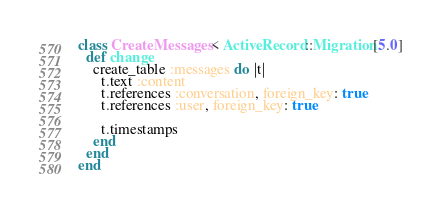<code> <loc_0><loc_0><loc_500><loc_500><_Ruby_>class CreateMessages < ActiveRecord::Migration[5.0]
  def change
    create_table :messages do |t|
      t.text :content
      t.references :conversation, foreign_key: true
      t.references :user, foreign_key: true

      t.timestamps
    end
  end
end
</code> 